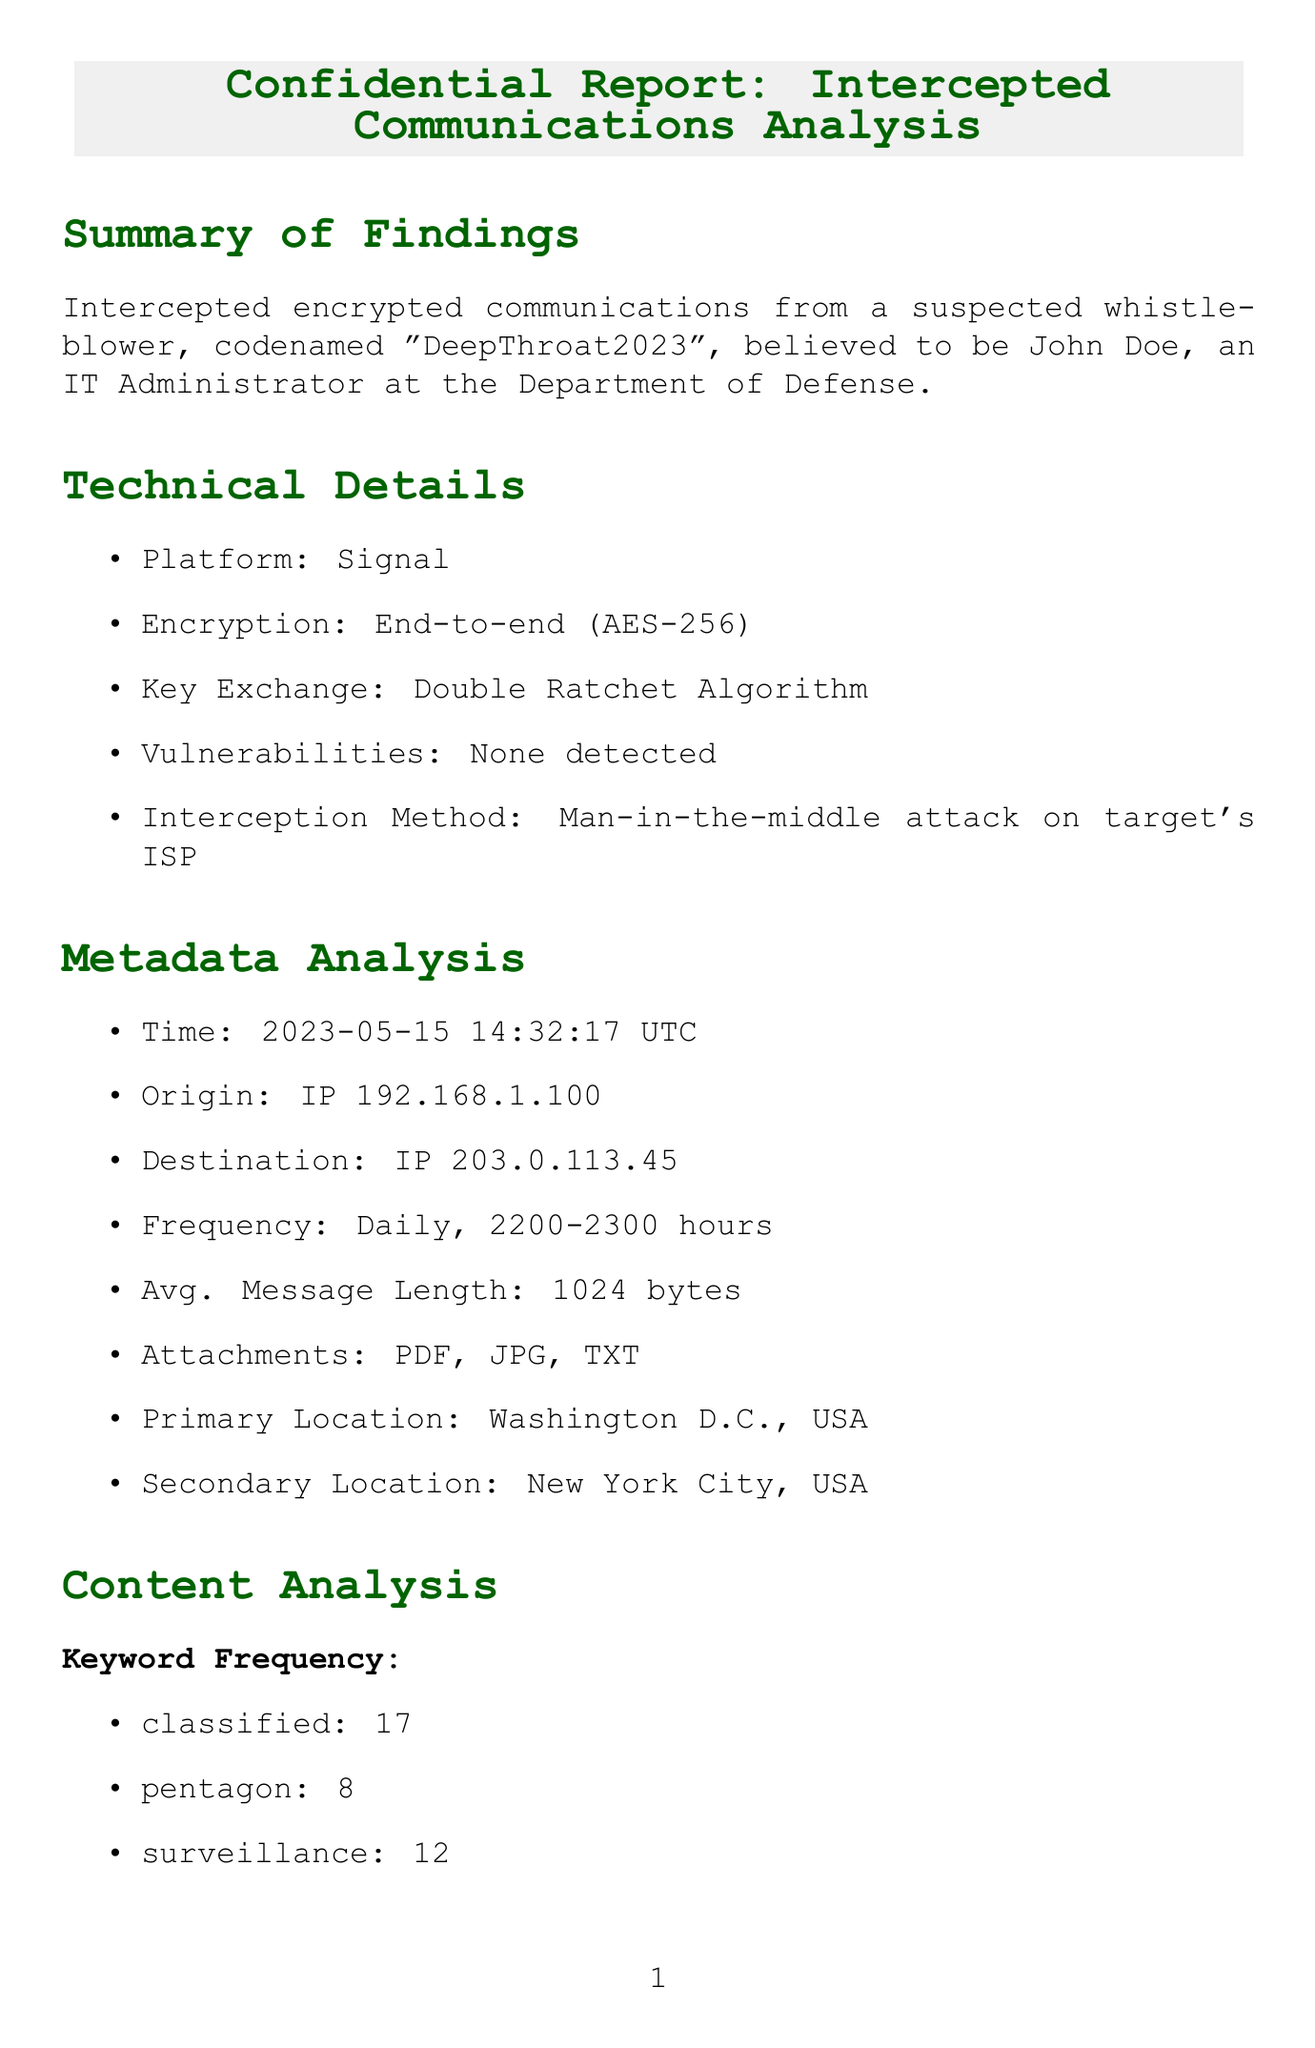what is the code name of the suspected whistleblower? The code name of the suspected whistleblower is mentioned in the document as "DeepThroat2023".
Answer: DeepThroat2023 what is the encryption type used in the intercepted communication? The type of encryption used is described in the technical details section as "End-to-end encryption".
Answer: End-to-end encryption what is the timestamp of the intercepted communication? The timestamp for the intercepted communication is explicitly provided in the metadata analysis section.
Answer: 2023-05-15 14:32:17 UTC how often does the communication occur? The communication frequency is specified in the metadata analysis section.
Answer: Daily, between 2200 and 2300 hours what is the average message length of the intercepted communication? The average message length is found in the metadata analysis section, which states the length.
Answer: 1024 bytes who are the known associates of the suspected whistleblower? The known associates of the suspected whistleblower are listed in the document and include specific names.
Answer: Jane Smith, Investigative Journalist at The Washington Post what are the recommended strategies for monitoring? The recommendations section outlines specific actions to take regarding monitoring activities.
Answer: Intensify monitoring of John Doe's activities within DoD networks how many times is the keyword "surveillance" mentioned? The keyword frequency section provides the count of keywords mentioned, including "surveillance".
Answer: 12 which algorithm is used for key exchange in the intercepted communication? The encryption technical details mention the algorithm used for key exchange in the communication.
Answer: Double Ratchet Algorithm 